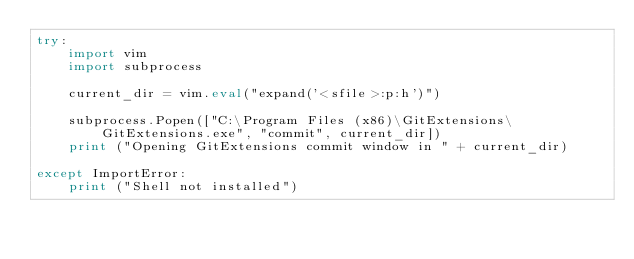Convert code to text. <code><loc_0><loc_0><loc_500><loc_500><_Python_>try:
    import vim
    import subprocess

    current_dir = vim.eval("expand('<sfile>:p:h')")

    subprocess.Popen(["C:\Program Files (x86)\GitExtensions\GitExtensions.exe", "commit", current_dir])
    print ("Opening GitExtensions commit window in " + current_dir)

except ImportError:
    print ("Shell not installed")
</code> 